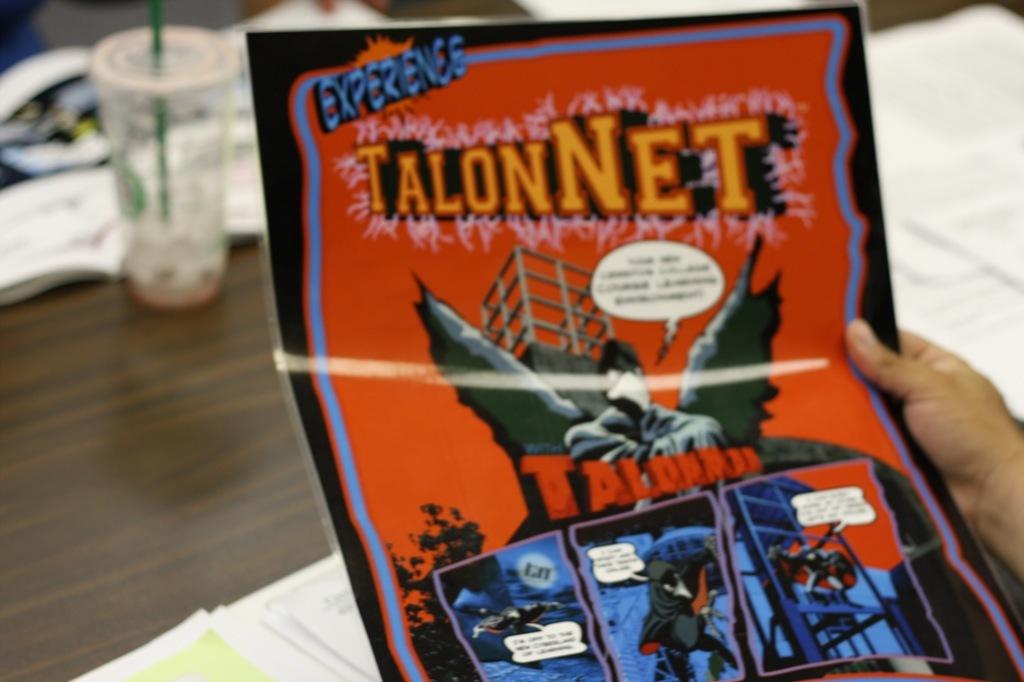Is talon net a comic book?
Keep it short and to the point. Yes. Who is the superhero on the poster?
Keep it short and to the point. Talonman. 